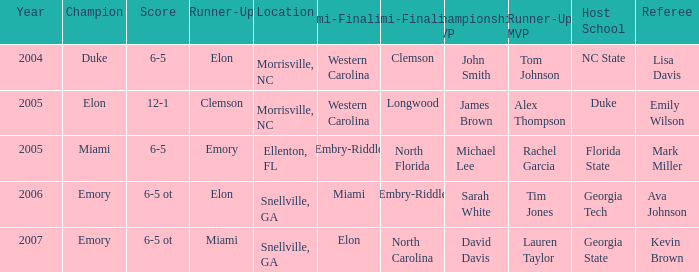What are the scores of all matches when miami was named the first semi-finalist? 6-5 ot. 